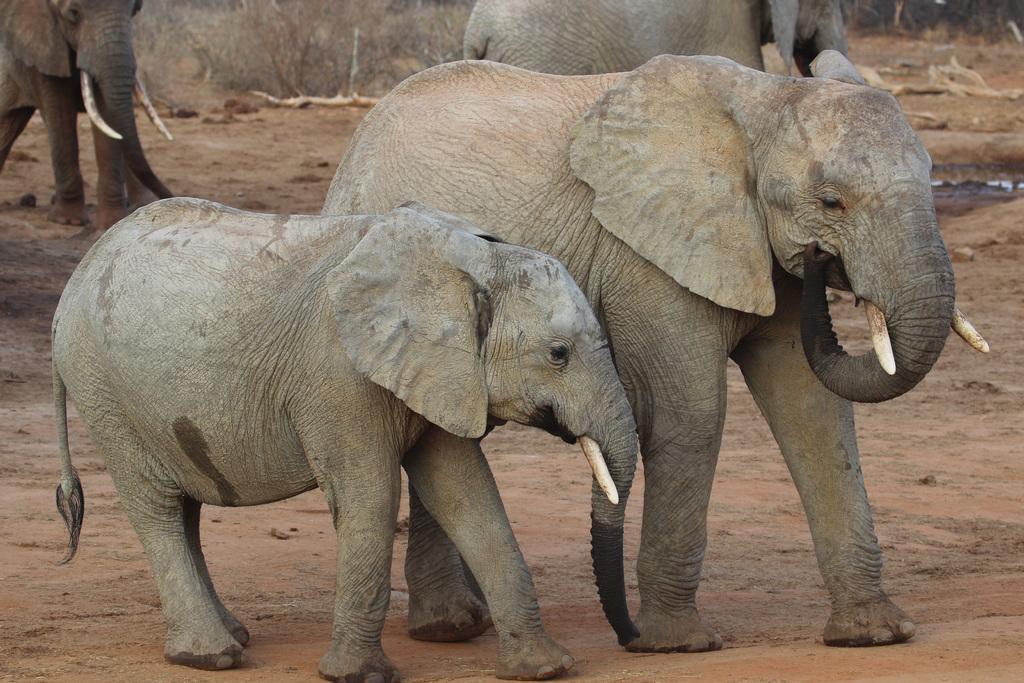How would you summarize this image in a sentence or two? In the image we can see there are four elephants, cement in color and there is a sand. 